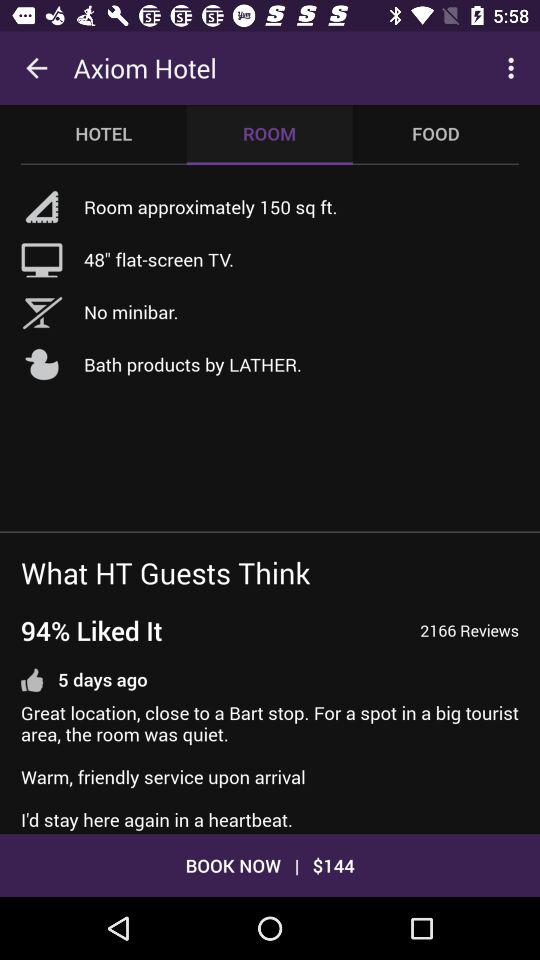Is there a minibar available? There is no minibar available. 